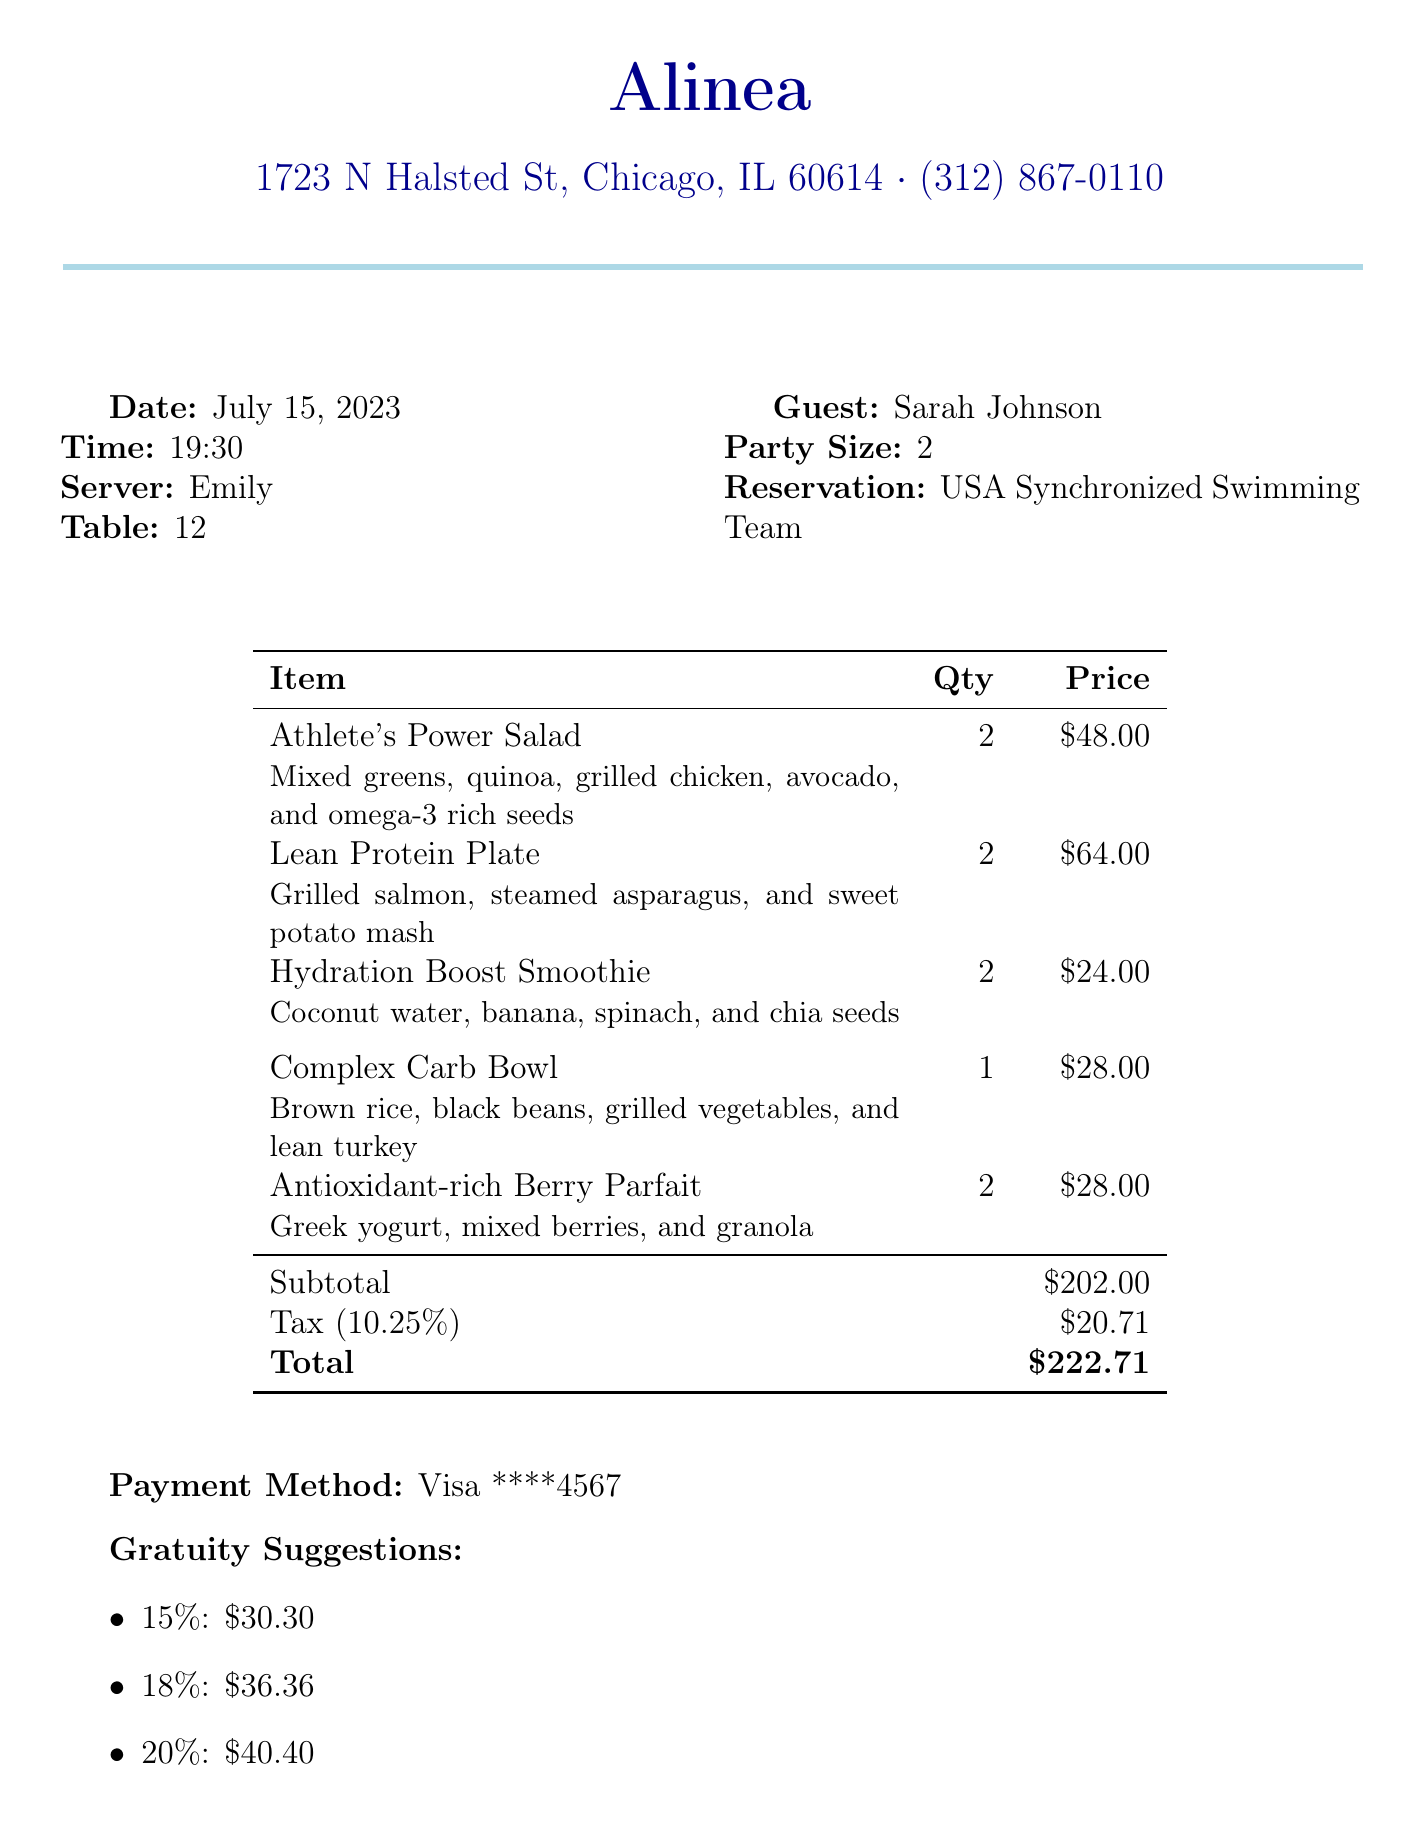What is the name of the restaurant? The name of the restaurant is clearly mentioned at the top of the document heading.
Answer: Alinea What date was the meal served? The date of the meal is specified in the document under the date heading.
Answer: July 15, 2023 How many guests were served? The number of guests can be found in the guest count section of the document.
Answer: 2 What is the total amount of the bill? The total amount is given towards the end of the document clearly labeled as the total.
Answer: $222.71 Who was the server? The name of the server is provided in the details section of the invoice.
Answer: Emily What dish contains grilled salmon? By reviewing the items on the menu, one can identify the dish that includes this ingredient.
Answer: Lean Protein Plate What is the price of the Hydration Boost Smoothie? The price for this specific item is listed in the items section of the document.
Answer: $12.00 What is the loyalty program name? The name of the loyalty program is stated towards the end of the document under loyalty program section.
Answer: Alinea Dining Rewards What are the gratuity suggestions for 18%? This information can be found in the gratuity suggestions section of the document.
Answer: $36.36 